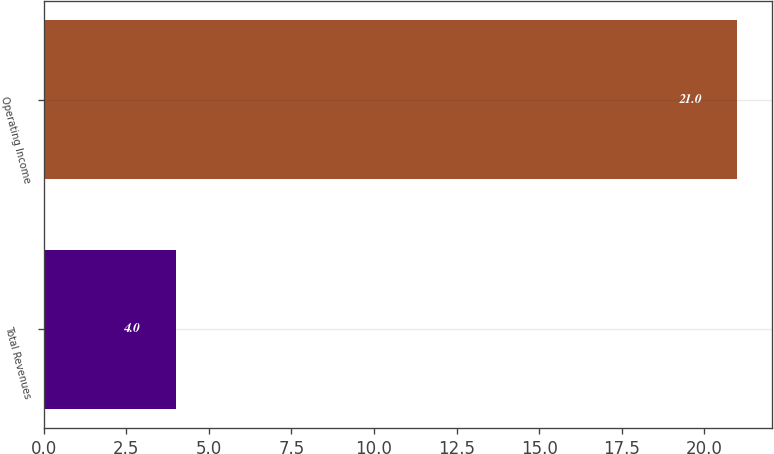Convert chart to OTSL. <chart><loc_0><loc_0><loc_500><loc_500><bar_chart><fcel>Total Revenues<fcel>Operating Income<nl><fcel>4<fcel>21<nl></chart> 